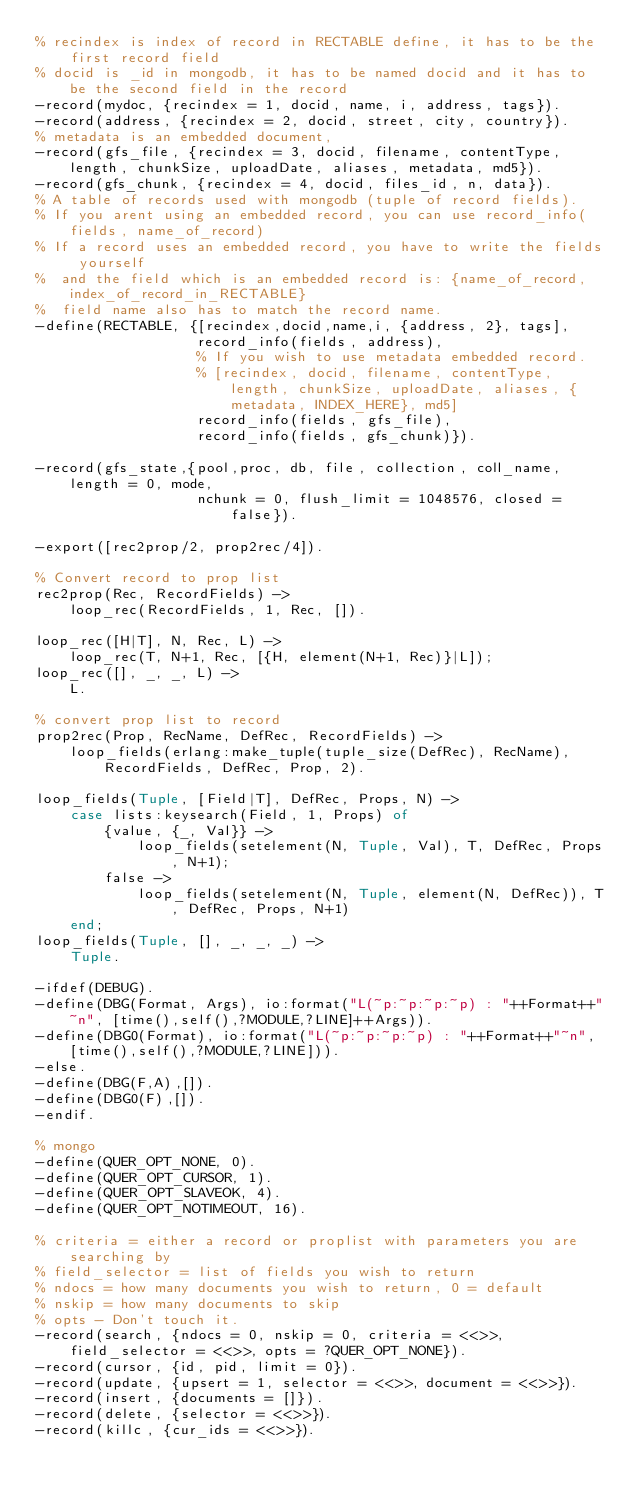<code> <loc_0><loc_0><loc_500><loc_500><_Erlang_>% recindex is index of record in RECTABLE define, it has to be the first record field
% docid is _id in mongodb, it has to be named docid and it has to be the second field in the record
-record(mydoc, {recindex = 1, docid, name, i, address, tags}).
-record(address, {recindex = 2, docid, street, city, country}).
% metadata is an embedded document,
-record(gfs_file, {recindex = 3, docid, filename, contentType, length, chunkSize, uploadDate, aliases, metadata, md5}).
-record(gfs_chunk, {recindex = 4, docid, files_id, n, data}).
% A table of records used with mongodb (tuple of record fields).
% If you arent using an embedded record, you can use record_info(fields, name_of_record)
% If a record uses an embedded record, you have to write the fields yourself
%  and the field which is an embedded record is: {name_of_record, index_of_record_in_RECTABLE}
%  field name also has to match the record name.
-define(RECTABLE, {[recindex,docid,name,i, {address, 2}, tags],
                   record_info(fields, address),
				   % If you wish to use metadata embedded record.
				   % [recindex, docid, filename, contentType, length, chunkSize, uploadDate, aliases, {metadata, INDEX_HERE}, md5]
				   record_info(fields, gfs_file),
				   record_info(fields, gfs_chunk)}).

-record(gfs_state,{pool,proc, db, file, collection, coll_name, length = 0, mode, 
				   nchunk = 0, flush_limit = 1048576, closed = false}).

-export([rec2prop/2, prop2rec/4]).

% Convert record to prop list	
rec2prop(Rec, RecordFields) ->
	loop_rec(RecordFields, 1, Rec, []).

loop_rec([H|T], N, Rec, L) ->
	loop_rec(T, N+1, Rec, [{H, element(N+1, Rec)}|L]);
loop_rec([], _, _, L) ->
	L.

% convert prop list to record
prop2rec(Prop, RecName, DefRec, RecordFields) ->
	loop_fields(erlang:make_tuple(tuple_size(DefRec), RecName), RecordFields, DefRec, Prop, 2).

loop_fields(Tuple, [Field|T], DefRec, Props, N) ->
	case lists:keysearch(Field, 1, Props) of
		{value, {_, Val}} ->
			loop_fields(setelement(N, Tuple, Val), T, DefRec, Props, N+1);
		false ->
			loop_fields(setelement(N, Tuple, element(N, DefRec)), T, DefRec, Props, N+1)
	end;
loop_fields(Tuple, [], _, _, _) ->
	Tuple.

-ifdef(DEBUG).
-define(DBG(Format, Args), io:format("L(~p:~p:~p:~p) : "++Format++"~n", [time(),self(),?MODULE,?LINE]++Args)).
-define(DBG0(Format), io:format("L(~p:~p:~p:~p) : "++Format++"~n", [time(),self(),?MODULE,?LINE])).
-else.
-define(DBG(F,A),[]).
-define(DBG0(F),[]).
-endif.
	
% mongo	
-define(QUER_OPT_NONE, 0).
-define(QUER_OPT_CURSOR, 1).
-define(QUER_OPT_SLAVEOK, 4).
-define(QUER_OPT_NOTIMEOUT, 16).

% criteria = either a record or proplist with parameters you are searching by
% field_selector = list of fields you wish to return
% ndocs = how many documents you wish to return, 0 = default
% nskip = how many documents to skip
% opts - Don't touch it.
-record(search, {ndocs = 0, nskip = 0, criteria = <<>>, field_selector = <<>>, opts = ?QUER_OPT_NONE}).
-record(cursor, {id, pid, limit = 0}).
-record(update, {upsert = 1, selector = <<>>, document = <<>>}).
-record(insert, {documents = []}).
-record(delete, {selector = <<>>}).
-record(killc, {cur_ids = <<>>}).	

</code> 